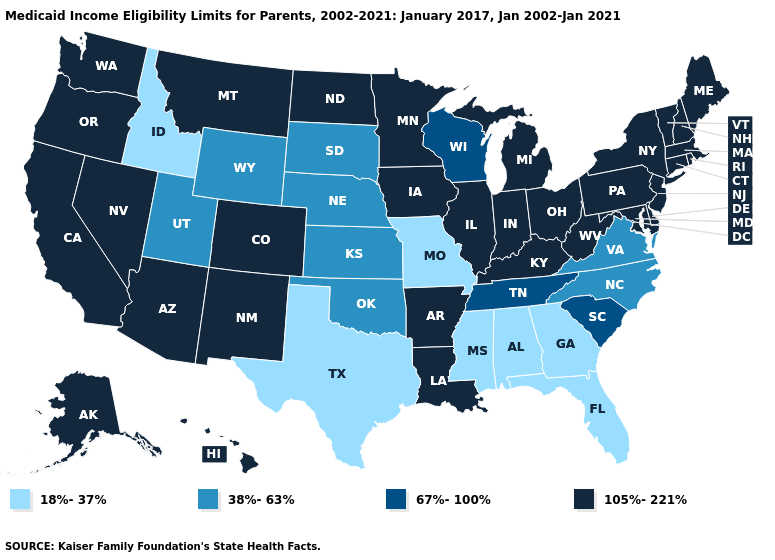What is the lowest value in the South?
Keep it brief. 18%-37%. What is the value of California?
Give a very brief answer. 105%-221%. Name the states that have a value in the range 67%-100%?
Give a very brief answer. South Carolina, Tennessee, Wisconsin. What is the lowest value in the West?
Answer briefly. 18%-37%. Name the states that have a value in the range 18%-37%?
Write a very short answer. Alabama, Florida, Georgia, Idaho, Mississippi, Missouri, Texas. Name the states that have a value in the range 67%-100%?
Keep it brief. South Carolina, Tennessee, Wisconsin. Name the states that have a value in the range 67%-100%?
Answer briefly. South Carolina, Tennessee, Wisconsin. What is the value of Idaho?
Concise answer only. 18%-37%. Does Rhode Island have a lower value than Washington?
Answer briefly. No. Does the map have missing data?
Concise answer only. No. Is the legend a continuous bar?
Write a very short answer. No. Name the states that have a value in the range 38%-63%?
Short answer required. Kansas, Nebraska, North Carolina, Oklahoma, South Dakota, Utah, Virginia, Wyoming. Name the states that have a value in the range 105%-221%?
Concise answer only. Alaska, Arizona, Arkansas, California, Colorado, Connecticut, Delaware, Hawaii, Illinois, Indiana, Iowa, Kentucky, Louisiana, Maine, Maryland, Massachusetts, Michigan, Minnesota, Montana, Nevada, New Hampshire, New Jersey, New Mexico, New York, North Dakota, Ohio, Oregon, Pennsylvania, Rhode Island, Vermont, Washington, West Virginia. What is the highest value in the USA?
Be succinct. 105%-221%. 